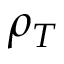<formula> <loc_0><loc_0><loc_500><loc_500>\rho _ { T }</formula> 